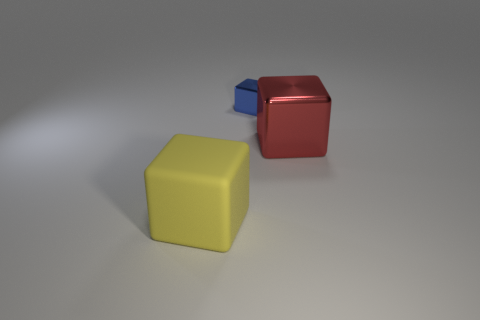Is there any other thing that has the same material as the yellow thing?
Ensure brevity in your answer.  No. Do the thing right of the blue thing and the big block left of the tiny shiny thing have the same material?
Your answer should be very brief. No. What material is the other large thing that is the same shape as the red metal thing?
Provide a short and direct response. Rubber. Are the object to the right of the tiny blue metallic block and the yellow block made of the same material?
Provide a short and direct response. No. There is a yellow object that is the same size as the red shiny cube; what is it made of?
Offer a very short reply. Rubber. There is a object to the left of the tiny blue block; what is its size?
Ensure brevity in your answer.  Large. What is the shape of the other red object that is the same size as the rubber thing?
Offer a very short reply. Cube. What number of objects are either large brown metal balls or objects behind the large red thing?
Offer a very short reply. 1. There is a metal thing that is to the left of the large thing that is right of the big rubber thing; what number of large yellow blocks are left of it?
Your response must be concise. 1. There is another thing that is the same material as the red thing; what color is it?
Offer a very short reply. Blue. 